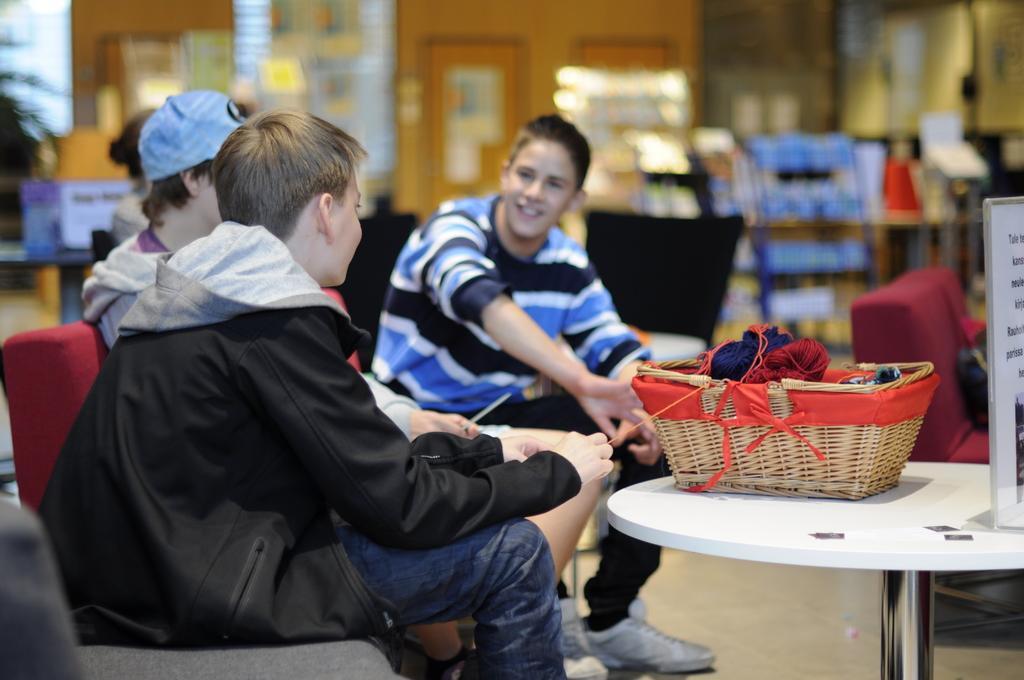Please provide a concise description of this image. This picture describes about group of people few are seated on the chair and they are talking in front of them we can see a basket on the table, in the background we can find a plant and couple of lights. 